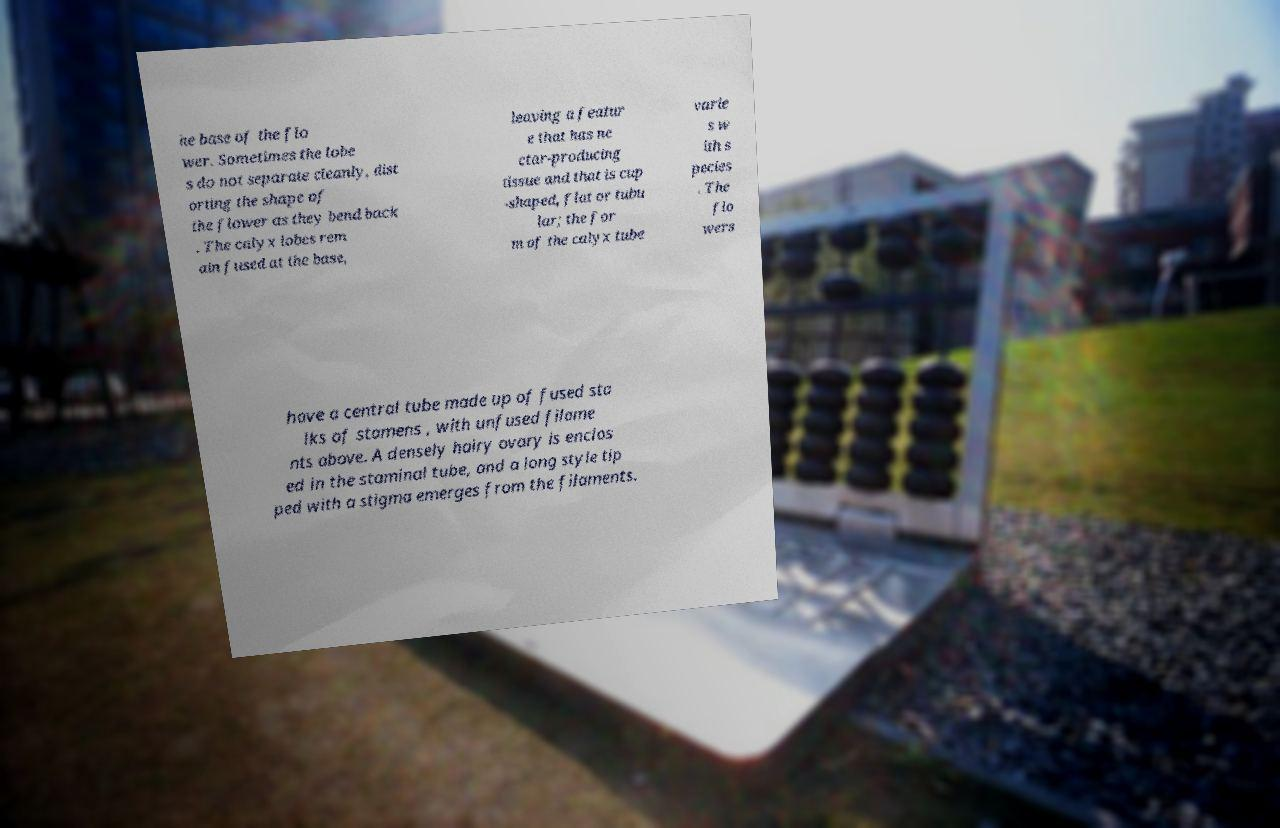Please identify and transcribe the text found in this image. he base of the flo wer. Sometimes the lobe s do not separate cleanly, dist orting the shape of the flower as they bend back . The calyx lobes rem ain fused at the base, leaving a featur e that has ne ctar-producing tissue and that is cup -shaped, flat or tubu lar; the for m of the calyx tube varie s w ith s pecies . The flo wers have a central tube made up of fused sta lks of stamens , with unfused filame nts above. A densely hairy ovary is enclos ed in the staminal tube, and a long style tip ped with a stigma emerges from the filaments. 